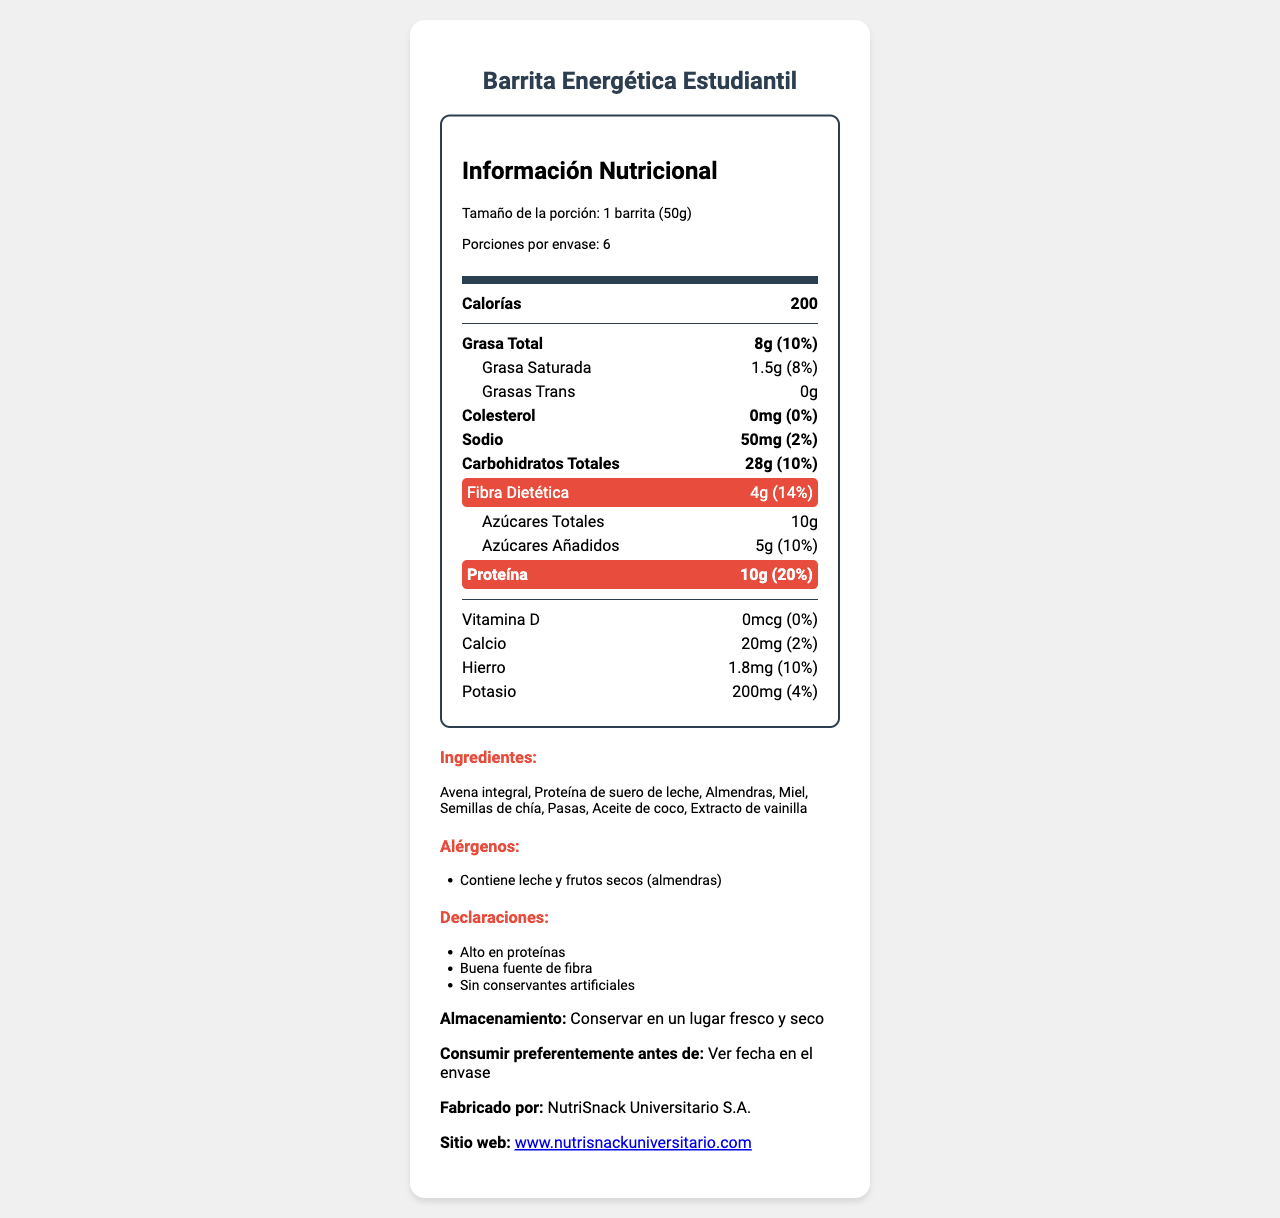what es el tamaño de la porción? El tamaño de la porción se menciona en la sección de información sobre las porciones.
Answer: 1 barrita (50g) ¿Cuántas calorías tiene una barrita? Las calorías están listadas como 200 en la sección principal de contenido nutricional.
Answer: 200 ¿Cuánto sodio contiene una porción? La cantidad de sodio por porción se encuentra en la sección de información nutricional.
Answer: 50mg ¿Cuál es el porcentaje del valor diario de fibra dietética en una porción? El valor diario de fibra dietética está listado como 14% junto a la cantidad de fibra (4g).
Answer: 14% ¿Cuáles son los ingredientes principales de la barrita energética? Los ingredientes están todos listados en una sección separada después de la información nutricional.
Answer: Avena integral, Proteína de suero de leche, Almendras, Miel, Semillas de chía, Pasas, Aceite de coco, Extracto de vainilla ¿Cuál es la cantidad total de proteína en una porción? La cantidad de proteína por porción se encuentra destacada en la sección de información nutricional.
Answer: 10g ¿Cuáles son los alérgenos presentes en la barrita? Los alérgenos están listados en una sección dedicada a esa información.
Answer: Contiene leche y frutos secos (almendras) ¿Es esta barrita una buena fuente de fibra? Esto se menciona en las declaraciones que indican que es una "Buena fuente de fibra".
Answer: Sí ¿Cuál es la fecha de caducidad? La sección del documento indica que se debe ver la fecha en el envase, por lo que no se proporciona una fecha específica.
Answer: Ver fecha en el envase ¿El producto contiene grasas trans? (Sí/No) El contenido de grasas trans se lista como 0g en la sección de información nutricional.
Answer: No ¿Cuál es la mejor manera de almacenar la barrita? Las instrucciones de almacenamiento se encuentran al final del documento.
Answer: Conservar en un lugar fresco y seco ¿Qué porcentaje del valor diario recomendado es la cantidad de proteína en una porción? A. 10% B. 14% C. 20% D. 25% La información nutricional muestra que la proteína proporciona el 20% del valor diario recomendado.
Answer: C. 20% ¿Cuál de los siguientes ingredientes no está incluido en la barrita? A. Pasas B. Avena integral C. Chocolate D. Aceite de coco Chocolate no aparece en la lista de ingredientes enumerados en el documento.
Answer: C. Chocolate Resuma el propósito del documento en una oración. Este resumen engloba la información clave presentada en el documento, que incluye tanto los aspectos nutricionales como los detalles adicionales sobre el producto.
Answer: El documento proporciona información nutricional, lista de ingredientes, alérgenos y detalles de almacenamiento para la "Barrita Energética Estudiantil". ¿La barrita es apta para una dieta baja en sodio? Si bien la barrita tiene solo 50mg de sodio, si en general se considera baja en sodio depende de la cantidad diaria total permitida en dicha dieta, lo que no se proporciona en el documento.
Answer: No hay suficiente información 